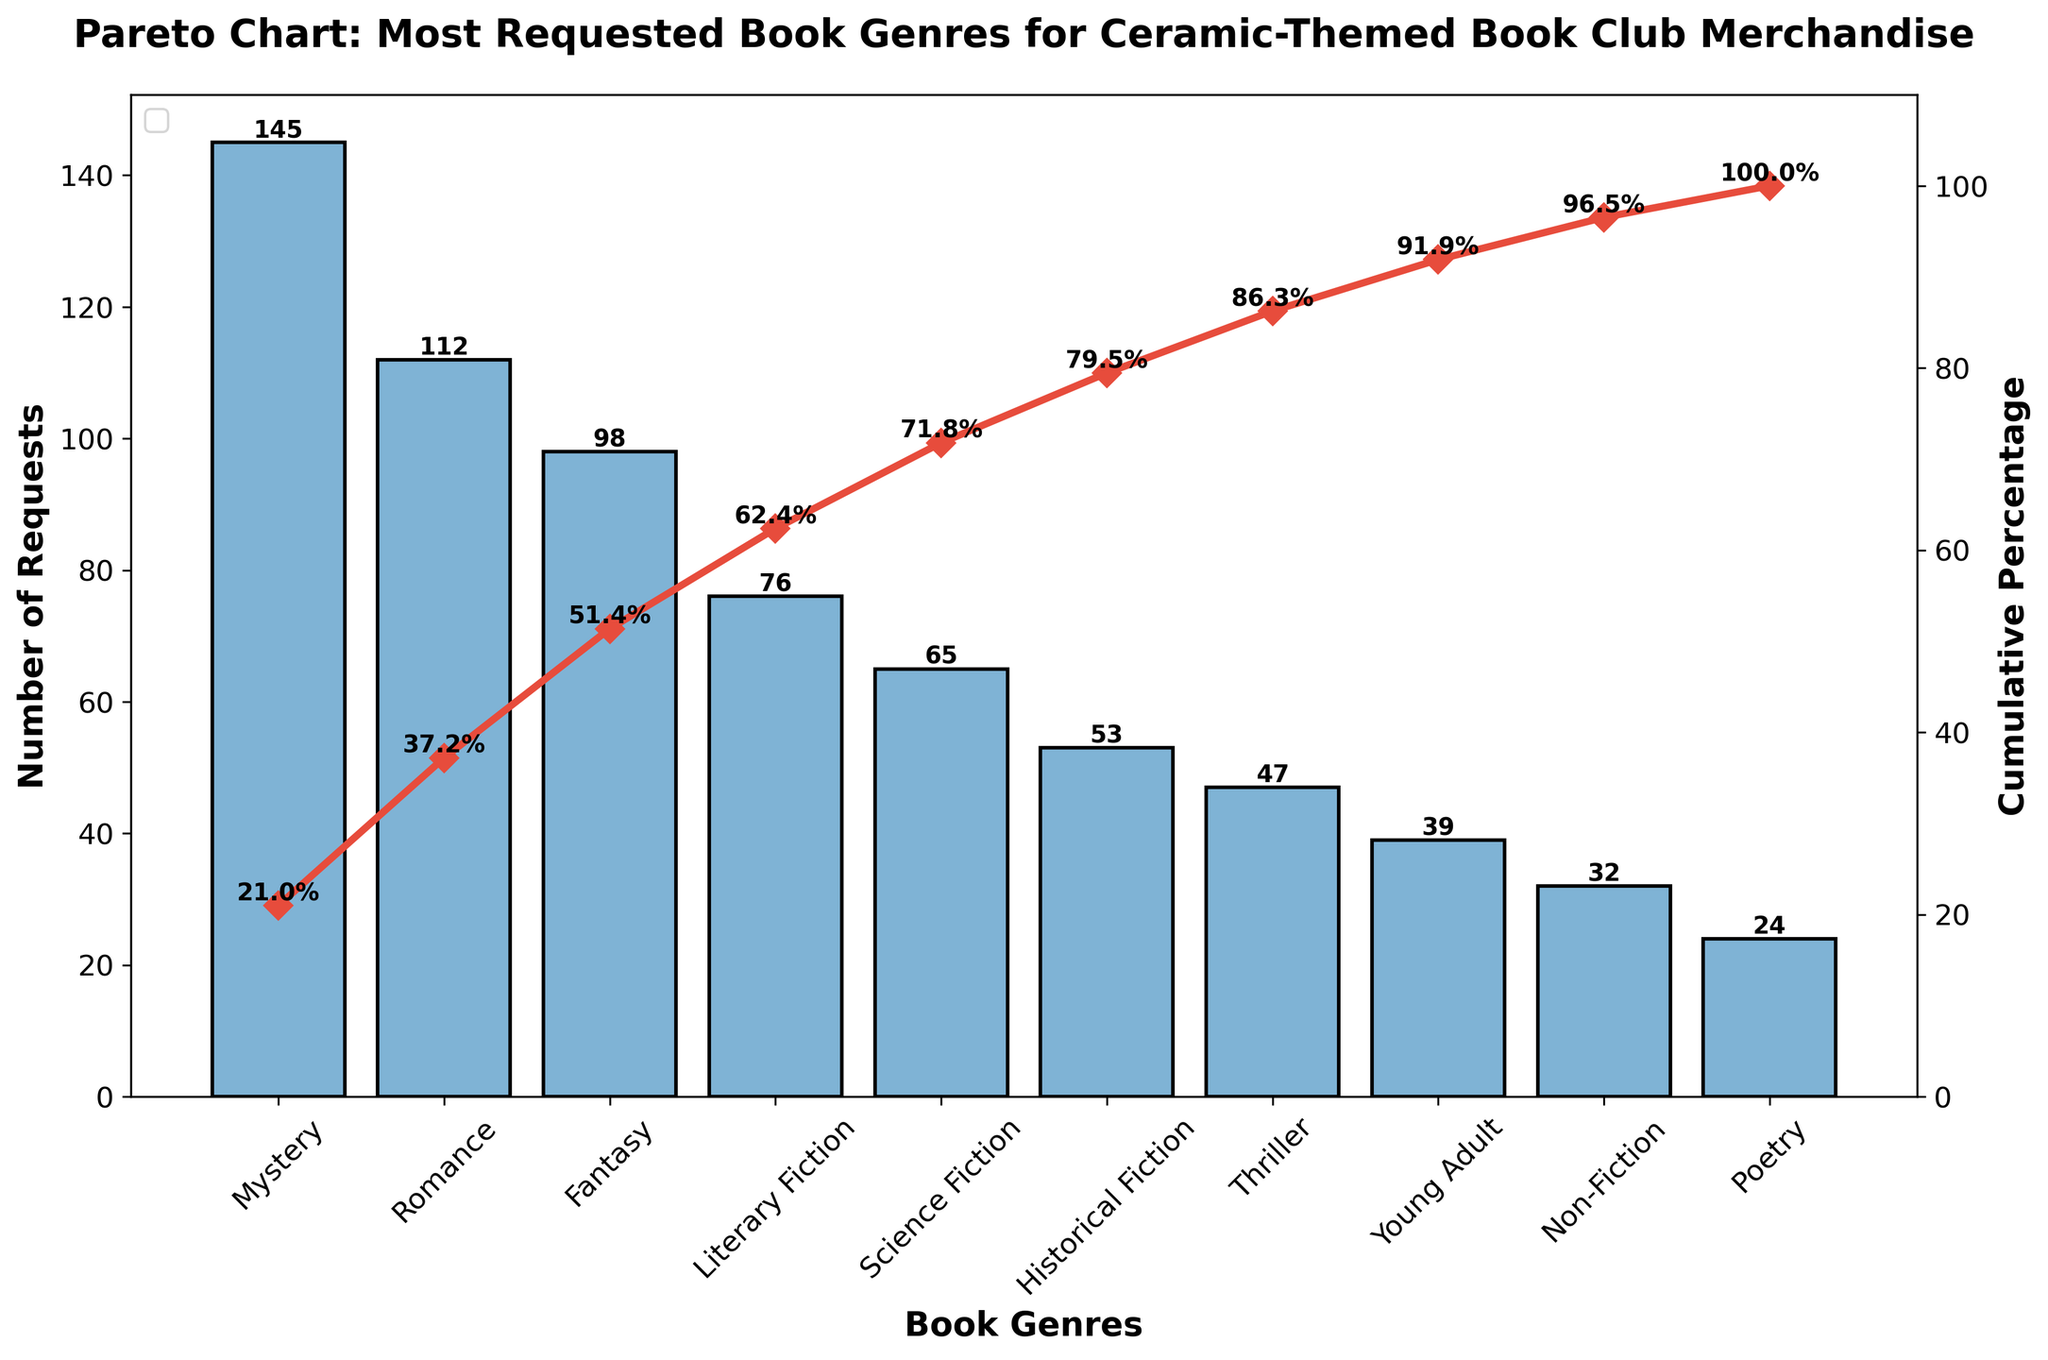What is the most requested book genre for ceramic-themed book club merchandise? The bar with the highest value represents the most requested genre, which is Mystery, with 145 requests.
Answer: Mystery What is the cumulative percentage of requests for the top three genres? The cumulative percentage for the top three genres (Mystery, Romance, and Fantasy) can be summed up directly from the cumulative percentage line: 29.5% (Mystery) + 52.2% (Romance) + 72.2% (Fantasy).
Answer: 72.2% Which genre is ranked fourth in terms of requests? Looking at the bar heights in descending order, the fourth highest bar represents Literary Fiction with 76 requests.
Answer: Literary Fiction How many total requests are there for the listed book genres? The total number of requests can be obtained by summing the individual requests for each genre: 145 + 112 + 98 + 76 + 65 + 53 + 47 + 39 + 32 + 24.
Answer: 691 What cumulative percentage of requests do the bottom five genres account for? The cumulative percentage for the bottom five genres (Thriller, Young Adult, Non-Fiction, Poetry) can be read directly from the cumulative percentage line: 86.2% (Young Adult) + 90.8% (Non-Fiction) + 94.5% (Poetry). Subtract 86.2% from 90.8% and then 90.8% from 94.5% to get the final cumulative percentage.
Answer: 29.2% Which genres account for more than 50% of the total requests? Looking at the cumulative percentage line, any genres before the cumulative percentage crosses 50% are needed. Mystery (29.5%) and Romance (52.2%) together contribute more than 50%.
Answer: Mystery and Romance How many requests are there in total for the Fiction genres combined? Sum up requests of Fiction genres: Mystery (145), Romance (112), Fantasy (98), Literary Fiction (76), Science Fiction (65), Historical Fiction (53), and Thriller (47).
Answer: 596 What is the difference in the number of requests between the most requested and least requested genres? The most requested is Mystery with 145 requests and the least requested is Poetry with 24 requests. Subtract 24 from 145.
Answer: 121 At what genre does the cumulative percentage first exceed 80%? Following the cumulative percentage line, it first exceeds 80% at the genre Historical Fiction (83.9%).
Answer: Historical Fiction What percentage of the requests come from the three least requested genres? Summing up the requests for the three least requested genres (Young Adult, Non-Fiction, Poetry): 39 + 32 + 24 = 95. Divide this sum by the total requests (691) and multiply by 100 to get the percentage.
Answer: 13.7% 